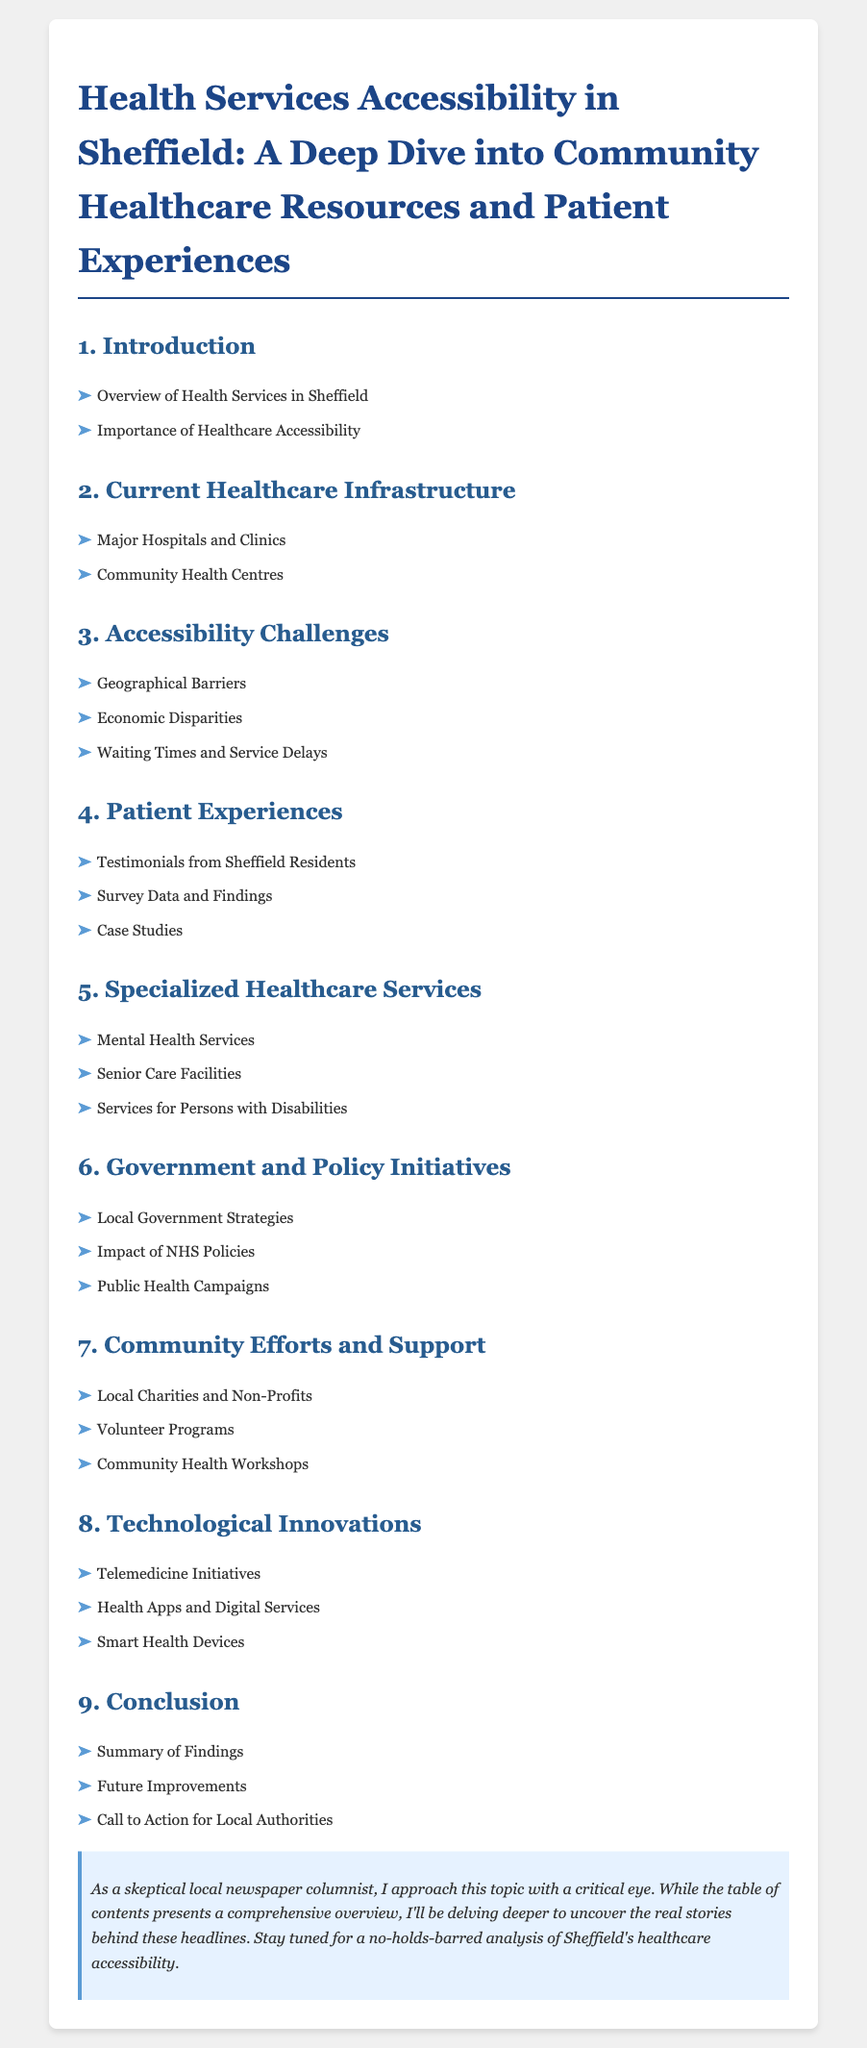What section covers Accessibility Challenges? The section that addresses Accessibility Challenges is indicated by the title in the table of contents.
Answer: 3. Accessibility Challenges How many main categories are listed in the document? The document's table of contents includes 9 main categories or sections.
Answer: 9 What type of services is discussed in section 5? Section 5 focuses on specific healthcare services available in the community, as indicated by its title.
Answer: Specialized Healthcare Services What does the document suggest about Government and Policy Initiatives? This section discusses local government strategies and their impacts as outlined in the table of contents.
Answer: 6. Government and Policy Initiatives What type of patient feedback is included in section 4? The fourth section contains personal experiences shared by residents of Sheffield, suggesting the focus of data collection.
Answer: Testimonials from Sheffield Residents 